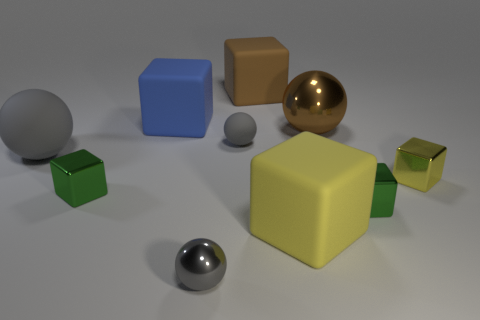There is a yellow shiny object that is in front of the ball that is to the right of the large brown thing that is behind the blue object; what is its shape?
Provide a succinct answer. Cube. Are there fewer tiny matte things than tiny gray things?
Make the answer very short. Yes. There is a large brown matte cube; are there any tiny rubber balls left of it?
Provide a short and direct response. Yes. There is a thing that is both behind the large rubber ball and to the right of the big yellow matte block; what is its shape?
Offer a very short reply. Sphere. Is there a large blue matte object of the same shape as the large brown metallic thing?
Your response must be concise. No. There is a matte ball to the right of the gray shiny thing; is it the same size as the gray thing that is in front of the large gray matte sphere?
Provide a succinct answer. Yes. Are there more small green things than things?
Offer a very short reply. No. How many large objects have the same material as the small yellow cube?
Your answer should be very brief. 1. Do the brown metal object and the tiny gray rubber object have the same shape?
Give a very brief answer. Yes. What is the size of the green cube on the right side of the gray sphere that is in front of the tiny yellow object on the right side of the yellow rubber block?
Give a very brief answer. Small. 